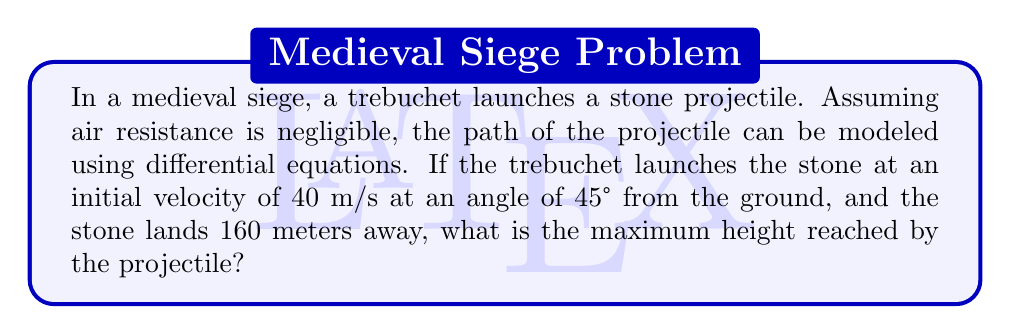Can you solve this math problem? Let's approach this step-by-step:

1) We can model the projectile motion using two differential equations:

   $$\frac{d^2x}{dt^2} = 0$$
   $$\frac{d^2y}{dt^2} = -g$$

   where $g$ is the acceleration due to gravity (9.8 m/s²).

2) Integrating these equations with respect to time:

   $$\frac{dx}{dt} = v_0 \cos\theta$$
   $$\frac{dy}{dt} = v_0 \sin\theta - gt$$

   where $v_0$ is the initial velocity and $\theta$ is the launch angle.

3) Integrating again:

   $$x = (v_0 \cos\theta)t$$
   $$y = (v_0 \sin\theta)t - \frac{1}{2}gt^2$$

4) We're given:
   $v_0 = 40$ m/s
   $\theta = 45°$
   $x = 160$ m (when $y = 0$)

5) To find the time of flight, we can use the x-equation:

   $$160 = (40 \cos 45°)t$$
   $$t = \frac{160}{40 \cos 45°} = \frac{160}{40 \cdot \frac{\sqrt{2}}{2}} = 5.66 \text{ seconds}$$

6) The maximum height occurs when $\frac{dy}{dt} = 0$:

   $$0 = v_0 \sin\theta - gt$$
   $$t = \frac{v_0 \sin\theta}{g} = \frac{40 \sin 45°}{9.8} = 2.83 \text{ seconds}$$

7) Plugging this time back into the y-equation:

   $$y_{max} = (40 \sin 45°)(2.83) - \frac{1}{2}(9.8)(2.83)^2$$
   $$y_{max} = (40 \cdot \frac{\sqrt{2}}{2})(2.83) - \frac{1}{2}(9.8)(2.83)^2$$
   $$y_{max} = 40.0 \text{ meters}$$

Therefore, the maximum height reached by the stone projectile is 40.0 meters.
Answer: 40.0 meters 